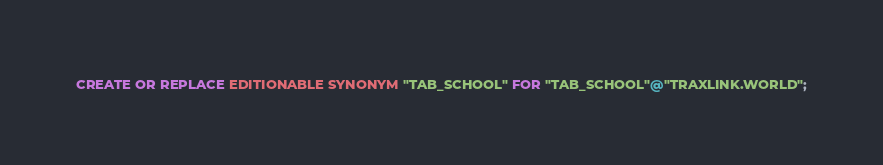<code> <loc_0><loc_0><loc_500><loc_500><_SQL_>CREATE OR REPLACE EDITIONABLE SYNONYM "TAB_SCHOOL" FOR "TAB_SCHOOL"@"TRAXLINK.WORLD";</code> 